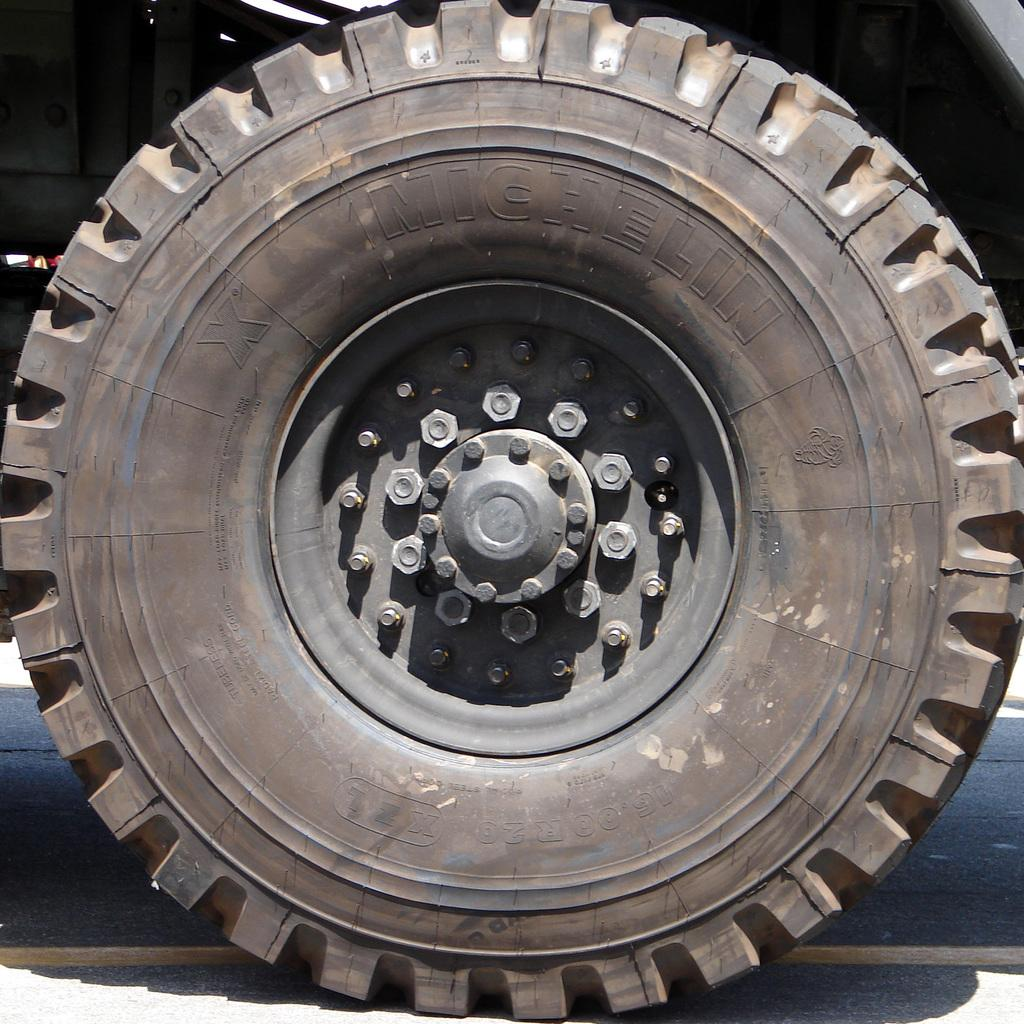What object can be seen in the image? There is a tire in the image. What else can be observed on the ground in the image? There is a shadow on the road in the image. What type of whistle can be heard coming from the tire in the image? There is no whistle present in the image, as it is a static image of a tire and a shadow on the road. 